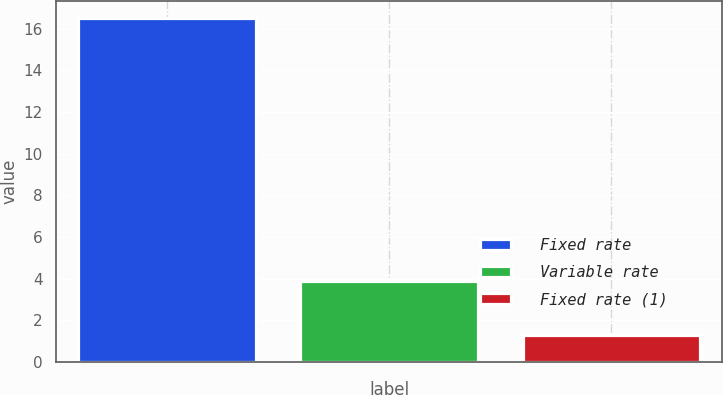<chart> <loc_0><loc_0><loc_500><loc_500><bar_chart><fcel>Fixed rate<fcel>Variable rate<fcel>Fixed rate (1)<nl><fcel>16.5<fcel>3.9<fcel>1.3<nl></chart> 